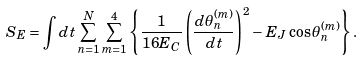Convert formula to latex. <formula><loc_0><loc_0><loc_500><loc_500>S _ { E } = \int d t \sum _ { n = 1 } ^ { N } \sum _ { m = 1 } ^ { 4 } \left \{ \frac { 1 } { 1 6 E _ { C } } \left ( \frac { d \theta ^ { ( m ) } _ { n } } { d t } \right ) ^ { 2 } - E _ { J } \cos \theta ^ { ( m ) } _ { n } \right \} .</formula> 